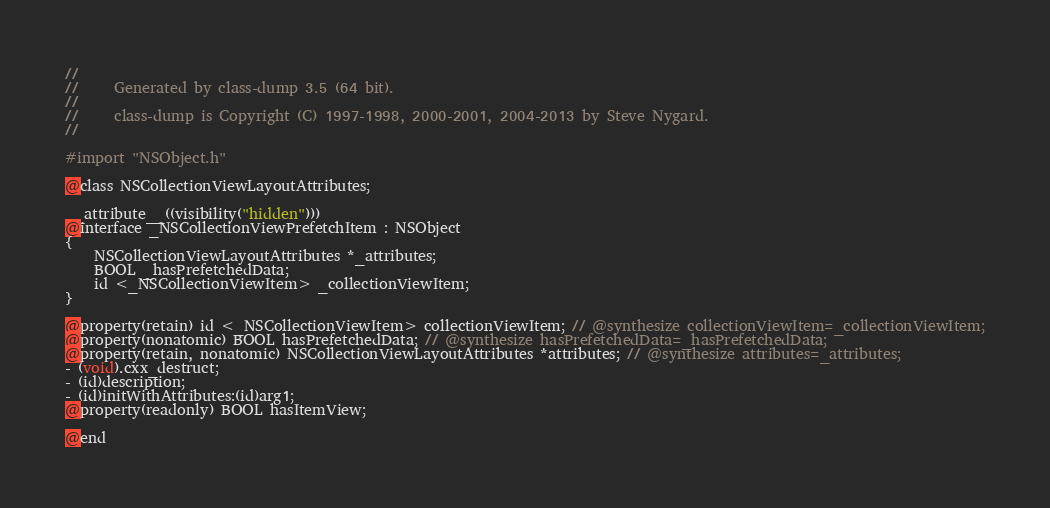<code> <loc_0><loc_0><loc_500><loc_500><_C_>//
//     Generated by class-dump 3.5 (64 bit).
//
//     class-dump is Copyright (C) 1997-1998, 2000-2001, 2004-2013 by Steve Nygard.
//

#import "NSObject.h"

@class NSCollectionViewLayoutAttributes;

__attribute__((visibility("hidden")))
@interface _NSCollectionViewPrefetchItem : NSObject
{
    NSCollectionViewLayoutAttributes *_attributes;
    BOOL _hasPrefetchedData;
    id <_NSCollectionViewItem> _collectionViewItem;
}

@property(retain) id <_NSCollectionViewItem> collectionViewItem; // @synthesize collectionViewItem=_collectionViewItem;
@property(nonatomic) BOOL hasPrefetchedData; // @synthesize hasPrefetchedData=_hasPrefetchedData;
@property(retain, nonatomic) NSCollectionViewLayoutAttributes *attributes; // @synthesize attributes=_attributes;
- (void).cxx_destruct;
- (id)description;
- (id)initWithAttributes:(id)arg1;
@property(readonly) BOOL hasItemView;

@end

</code> 